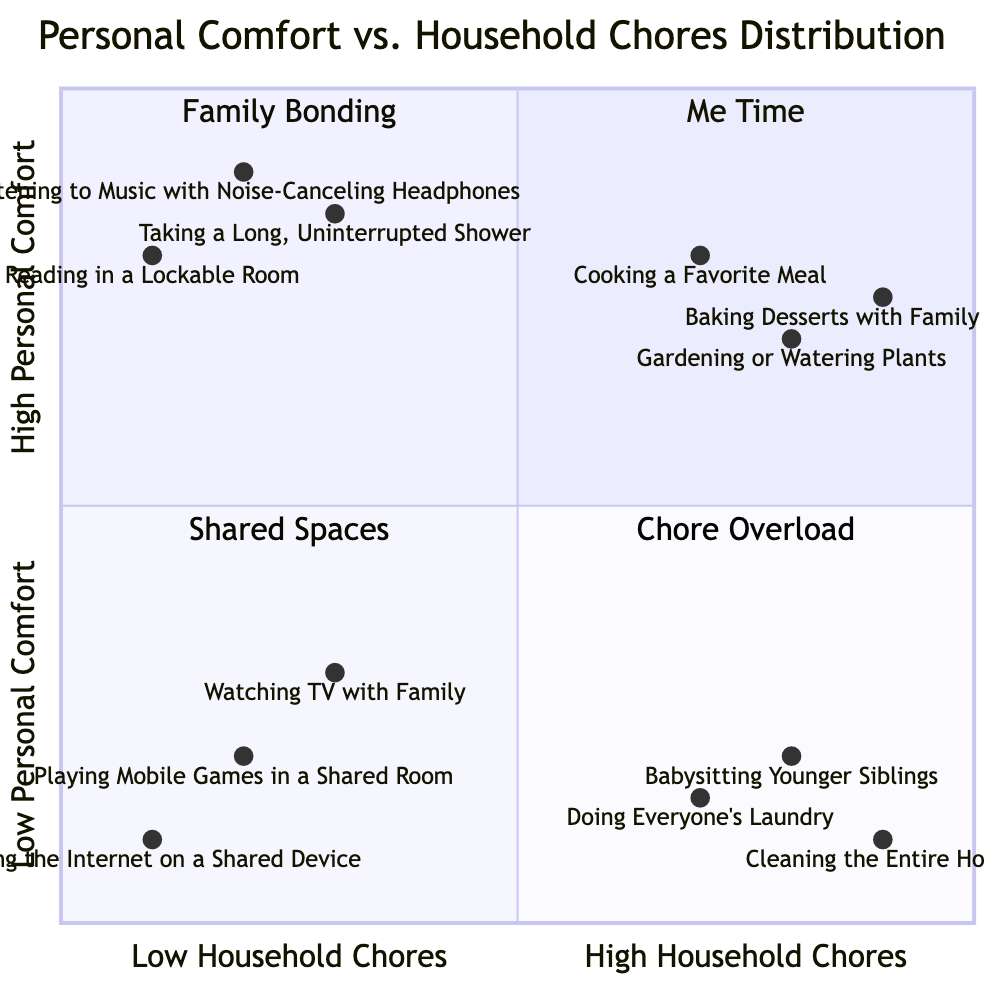What activities fall under High Personal Comfort/Low Household Chores? The quadrant titled "Me Time" represents high personal comfort with low household chores. It includes activities such as Listening to Music with Noise-Canceling Headphones, Reading in a Lockable Room, and Taking a Long, Uninterrupted Shower.
Answer: Listening to Music with Noise-Canceling Headphones, Reading in a Lockable Room, Taking a Long, Uninterrupted Shower How many activities are in the Low Personal Comfort/High Household Chores quadrant? The quadrant labeled "Chore Overload" contains three activities: Cleaning the Entire House, Babysitting Younger Siblings, and Doing Everyone's Laundry, thus having three activities in total.
Answer: 3 Which activity is in the Family Bonding quadrant? The quadrant labeled "Family Bonding" shows high personal comfort and high household chores, including activities like Cooking a Favorite Meal, Gardening or Watering Plants, and Baking Desserts with Family Members.
Answer: Cooking a Favorite Meal, Gardening or Watering Plants, Baking Desserts with Family Members Which activity has the highest personal comfort rating? The activity with the highest personal comfort rating in the quadrants is Taking a Long, Uninterrupted Shower, located at the coordinates [0.3, 0.85], indicating a high level of personal comfort compared to others in the chart.
Answer: Taking a Long, Uninterrupted Shower What is the relationship between Playing Mobile Games in a Shared Room and Watching TV with Family? Both activities are categorized in the Low Personal Comfort/Low Household Chores quadrant. While Watching TV with Family has a comfort rating of [0.3, 0.3] and Playing Mobile Games in a Shared Room is at [0.2, 0.2], they both indicate low personal comfort and low household chores.
Answer: Both are in the Low Personal Comfort/Low Household Chores quadrant 